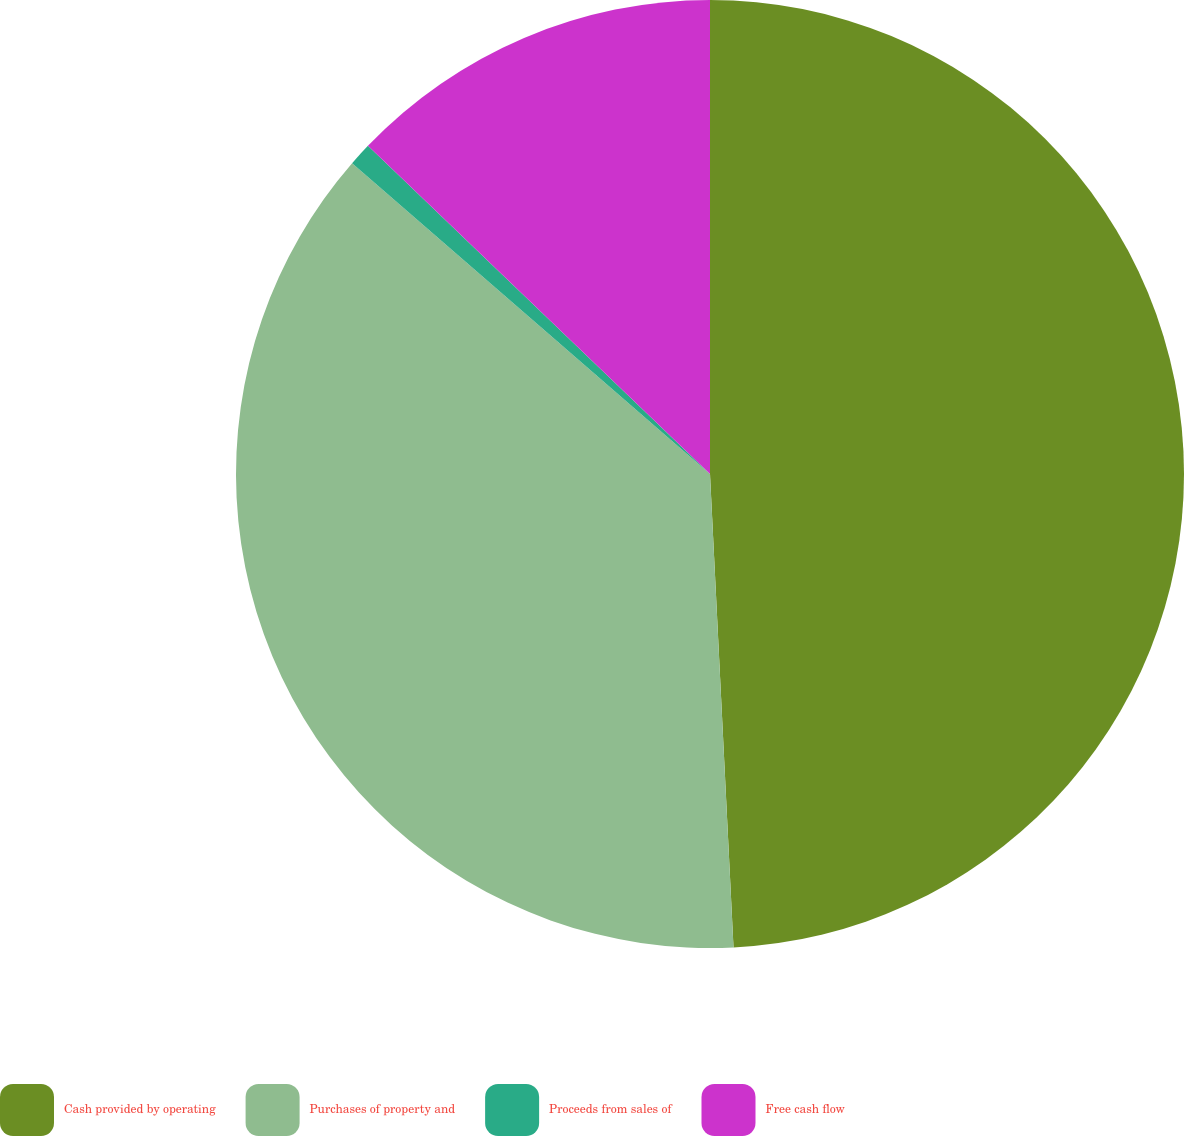Convert chart. <chart><loc_0><loc_0><loc_500><loc_500><pie_chart><fcel>Cash provided by operating<fcel>Purchases of property and<fcel>Proceeds from sales of<fcel>Free cash flow<nl><fcel>49.21%<fcel>37.17%<fcel>0.79%<fcel>12.83%<nl></chart> 